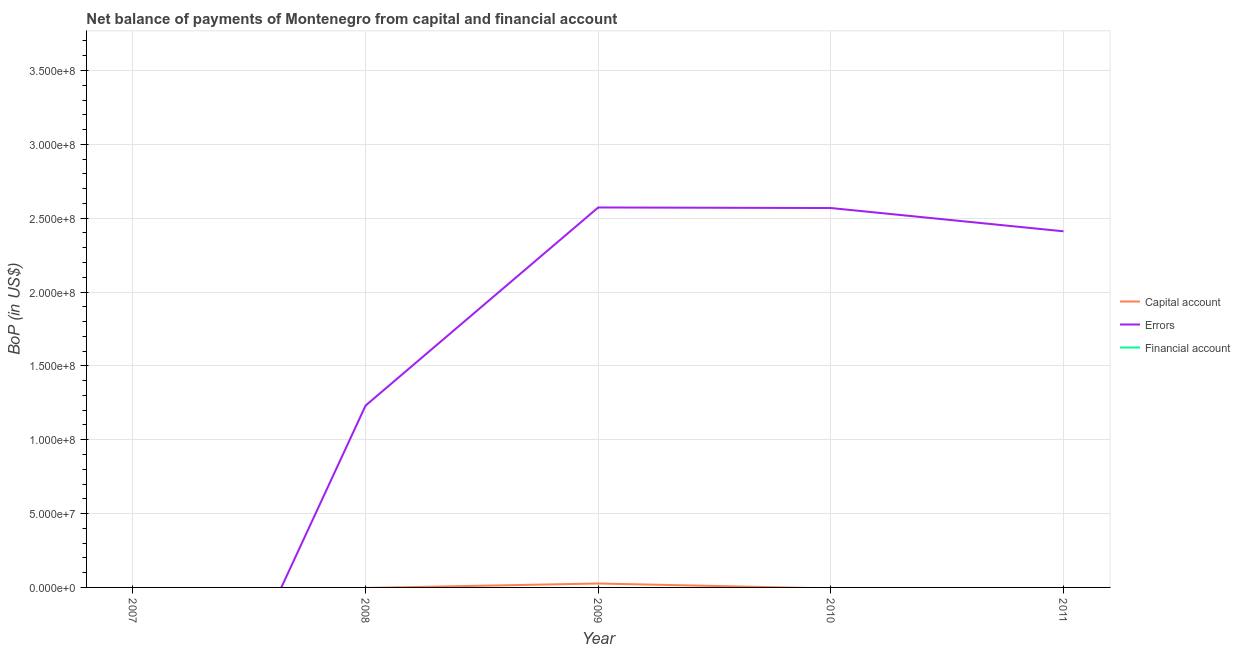Is the number of lines equal to the number of legend labels?
Offer a very short reply. No. Across all years, what is the maximum amount of errors?
Offer a terse response. 2.57e+08. Across all years, what is the minimum amount of financial account?
Provide a short and direct response. 0. What is the total amount of net capital account in the graph?
Offer a very short reply. 2.66e+06. What is the difference between the amount of errors in 2009 and that in 2010?
Your answer should be very brief. 3.79e+05. What is the difference between the amount of net capital account in 2007 and the amount of errors in 2008?
Provide a short and direct response. -1.23e+08. What is the ratio of the amount of errors in 2008 to that in 2009?
Ensure brevity in your answer.  0.48. What is the difference between the highest and the second highest amount of errors?
Ensure brevity in your answer.  3.79e+05. What is the difference between the highest and the lowest amount of errors?
Ensure brevity in your answer.  2.57e+08. Is the sum of the amount of errors in 2009 and 2011 greater than the maximum amount of financial account across all years?
Your answer should be very brief. Yes. How many lines are there?
Offer a very short reply. 2. How many years are there in the graph?
Make the answer very short. 5. Are the values on the major ticks of Y-axis written in scientific E-notation?
Provide a short and direct response. Yes. Does the graph contain any zero values?
Your response must be concise. Yes. Does the graph contain grids?
Provide a short and direct response. Yes. How many legend labels are there?
Offer a very short reply. 3. How are the legend labels stacked?
Provide a succinct answer. Vertical. What is the title of the graph?
Provide a succinct answer. Net balance of payments of Montenegro from capital and financial account. What is the label or title of the Y-axis?
Your response must be concise. BoP (in US$). What is the BoP (in US$) in Financial account in 2007?
Your answer should be compact. 0. What is the BoP (in US$) of Errors in 2008?
Make the answer very short. 1.23e+08. What is the BoP (in US$) of Capital account in 2009?
Offer a terse response. 2.66e+06. What is the BoP (in US$) of Errors in 2009?
Provide a short and direct response. 2.57e+08. What is the BoP (in US$) in Errors in 2010?
Offer a terse response. 2.57e+08. What is the BoP (in US$) of Errors in 2011?
Give a very brief answer. 2.41e+08. What is the BoP (in US$) of Financial account in 2011?
Provide a succinct answer. 0. Across all years, what is the maximum BoP (in US$) of Capital account?
Your answer should be very brief. 2.66e+06. Across all years, what is the maximum BoP (in US$) of Errors?
Provide a succinct answer. 2.57e+08. What is the total BoP (in US$) in Capital account in the graph?
Offer a very short reply. 2.66e+06. What is the total BoP (in US$) in Errors in the graph?
Your response must be concise. 8.78e+08. What is the total BoP (in US$) in Financial account in the graph?
Keep it short and to the point. 0. What is the difference between the BoP (in US$) of Errors in 2008 and that in 2009?
Your answer should be compact. -1.34e+08. What is the difference between the BoP (in US$) of Errors in 2008 and that in 2010?
Offer a very short reply. -1.34e+08. What is the difference between the BoP (in US$) of Errors in 2008 and that in 2011?
Your answer should be compact. -1.18e+08. What is the difference between the BoP (in US$) of Errors in 2009 and that in 2010?
Offer a terse response. 3.79e+05. What is the difference between the BoP (in US$) in Errors in 2009 and that in 2011?
Keep it short and to the point. 1.61e+07. What is the difference between the BoP (in US$) in Errors in 2010 and that in 2011?
Offer a terse response. 1.58e+07. What is the difference between the BoP (in US$) of Capital account in 2009 and the BoP (in US$) of Errors in 2010?
Make the answer very short. -2.54e+08. What is the difference between the BoP (in US$) in Capital account in 2009 and the BoP (in US$) in Errors in 2011?
Your answer should be compact. -2.38e+08. What is the average BoP (in US$) in Capital account per year?
Offer a very short reply. 5.33e+05. What is the average BoP (in US$) of Errors per year?
Offer a very short reply. 1.76e+08. What is the average BoP (in US$) of Financial account per year?
Offer a very short reply. 0. In the year 2009, what is the difference between the BoP (in US$) of Capital account and BoP (in US$) of Errors?
Give a very brief answer. -2.55e+08. What is the ratio of the BoP (in US$) of Errors in 2008 to that in 2009?
Provide a short and direct response. 0.48. What is the ratio of the BoP (in US$) of Errors in 2008 to that in 2010?
Your response must be concise. 0.48. What is the ratio of the BoP (in US$) of Errors in 2008 to that in 2011?
Your answer should be very brief. 0.51. What is the ratio of the BoP (in US$) in Errors in 2009 to that in 2010?
Your answer should be compact. 1. What is the ratio of the BoP (in US$) of Errors in 2009 to that in 2011?
Provide a succinct answer. 1.07. What is the ratio of the BoP (in US$) of Errors in 2010 to that in 2011?
Provide a succinct answer. 1.07. What is the difference between the highest and the second highest BoP (in US$) in Errors?
Ensure brevity in your answer.  3.79e+05. What is the difference between the highest and the lowest BoP (in US$) in Capital account?
Provide a succinct answer. 2.66e+06. What is the difference between the highest and the lowest BoP (in US$) of Errors?
Offer a terse response. 2.57e+08. 